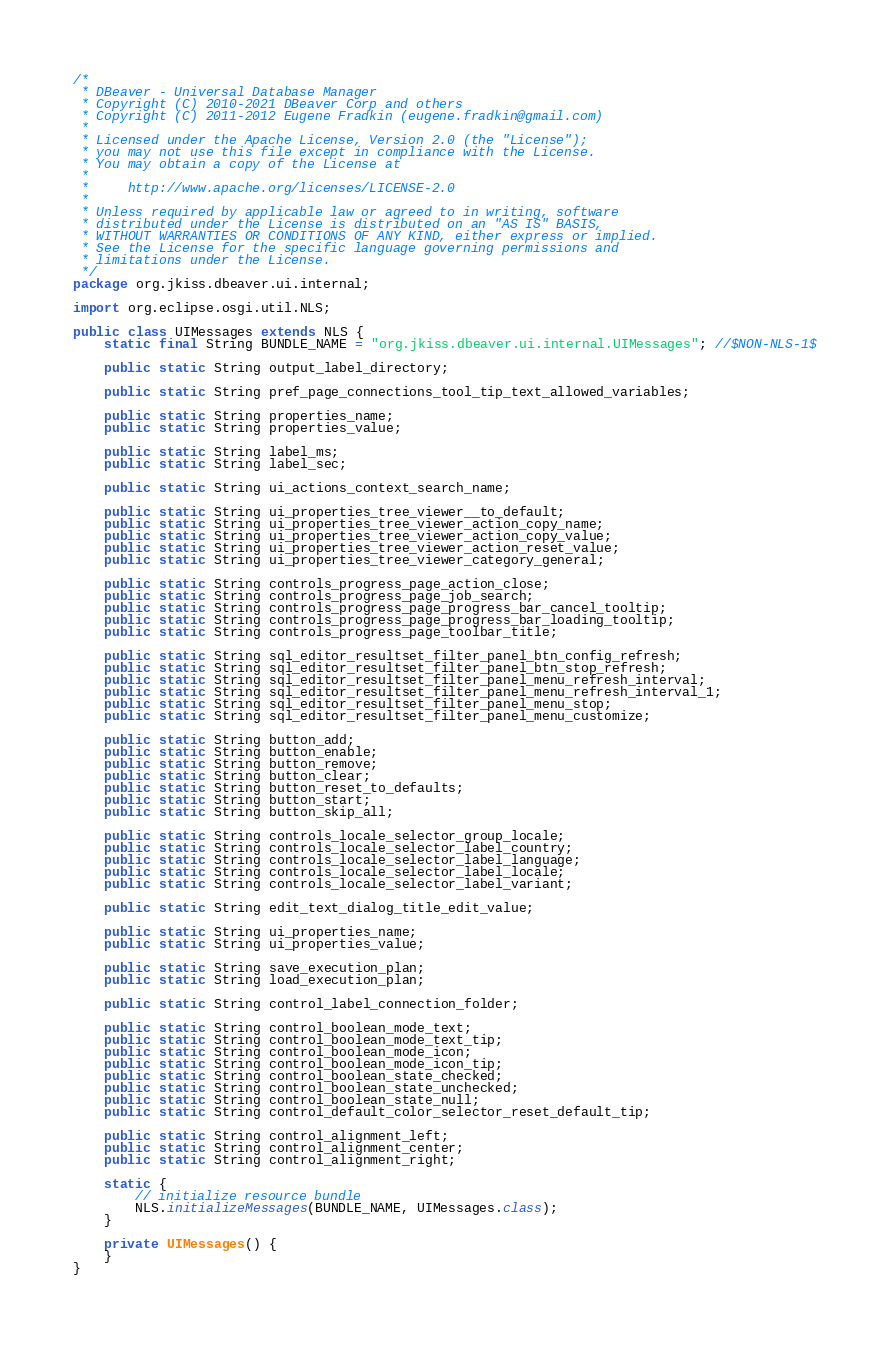<code> <loc_0><loc_0><loc_500><loc_500><_Java_>/*
 * DBeaver - Universal Database Manager
 * Copyright (C) 2010-2021 DBeaver Corp and others
 * Copyright (C) 2011-2012 Eugene Fradkin (eugene.fradkin@gmail.com)
 *
 * Licensed under the Apache License, Version 2.0 (the "License");
 * you may not use this file except in compliance with the License.
 * You may obtain a copy of the License at
 *
 *     http://www.apache.org/licenses/LICENSE-2.0
 *
 * Unless required by applicable law or agreed to in writing, software
 * distributed under the License is distributed on an "AS IS" BASIS,
 * WITHOUT WARRANTIES OR CONDITIONS OF ANY KIND, either express or implied.
 * See the License for the specific language governing permissions and
 * limitations under the License.
 */
package org.jkiss.dbeaver.ui.internal;

import org.eclipse.osgi.util.NLS;

public class UIMessages extends NLS {
    static final String BUNDLE_NAME = "org.jkiss.dbeaver.ui.internal.UIMessages"; //$NON-NLS-1$

    public static String output_label_directory;

    public static String pref_page_connections_tool_tip_text_allowed_variables;

    public static String properties_name;
    public static String properties_value;

    public static String label_ms;
    public static String label_sec;

    public static String ui_actions_context_search_name;

    public static String ui_properties_tree_viewer__to_default;
    public static String ui_properties_tree_viewer_action_copy_name;
    public static String ui_properties_tree_viewer_action_copy_value;
    public static String ui_properties_tree_viewer_action_reset_value;
    public static String ui_properties_tree_viewer_category_general;

    public static String controls_progress_page_action_close;
    public static String controls_progress_page_job_search;
    public static String controls_progress_page_progress_bar_cancel_tooltip;
    public static String controls_progress_page_progress_bar_loading_tooltip;
    public static String controls_progress_page_toolbar_title;

    public static String sql_editor_resultset_filter_panel_btn_config_refresh;
    public static String sql_editor_resultset_filter_panel_btn_stop_refresh;
    public static String sql_editor_resultset_filter_panel_menu_refresh_interval;
    public static String sql_editor_resultset_filter_panel_menu_refresh_interval_1;
    public static String sql_editor_resultset_filter_panel_menu_stop;
    public static String sql_editor_resultset_filter_panel_menu_customize;

    public static String button_add;
    public static String button_enable;
    public static String button_remove;
    public static String button_clear;
    public static String button_reset_to_defaults;
    public static String button_start;
    public static String button_skip_all;

    public static String controls_locale_selector_group_locale;
    public static String controls_locale_selector_label_country;
    public static String controls_locale_selector_label_language;
    public static String controls_locale_selector_label_locale;
    public static String controls_locale_selector_label_variant;

    public static String edit_text_dialog_title_edit_value;

    public static String ui_properties_name;
    public static String ui_properties_value;
    
    public static String save_execution_plan;
    public static String load_execution_plan;

    public static String control_label_connection_folder;

    public static String control_boolean_mode_text;
    public static String control_boolean_mode_text_tip;
    public static String control_boolean_mode_icon;
    public static String control_boolean_mode_icon_tip;
    public static String control_boolean_state_checked;
    public static String control_boolean_state_unchecked;
    public static String control_boolean_state_null;
    public static String control_default_color_selector_reset_default_tip;

    public static String control_alignment_left;
    public static String control_alignment_center;
    public static String control_alignment_right;

    static {
        // initialize resource bundle
        NLS.initializeMessages(BUNDLE_NAME, UIMessages.class);
    }

    private UIMessages() {
    }
}
</code> 